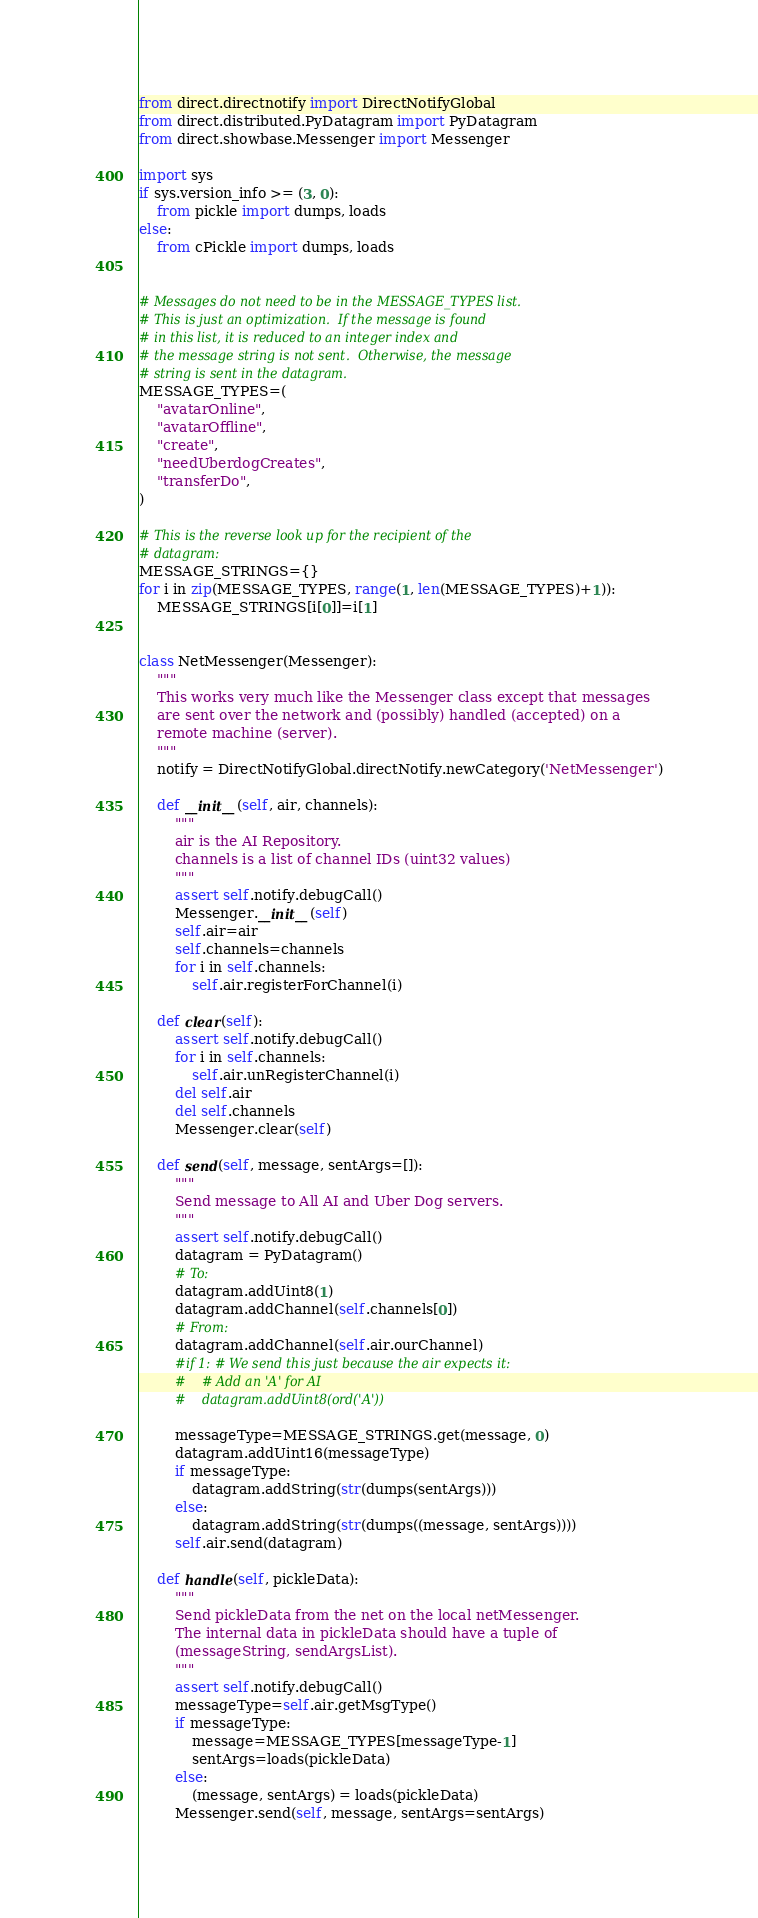Convert code to text. <code><loc_0><loc_0><loc_500><loc_500><_Python_>
from direct.directnotify import DirectNotifyGlobal
from direct.distributed.PyDatagram import PyDatagram
from direct.showbase.Messenger import Messenger

import sys
if sys.version_info >= (3, 0):
    from pickle import dumps, loads
else:
    from cPickle import dumps, loads


# Messages do not need to be in the MESSAGE_TYPES list.
# This is just an optimization.  If the message is found
# in this list, it is reduced to an integer index and
# the message string is not sent.  Otherwise, the message
# string is sent in the datagram.
MESSAGE_TYPES=(
    "avatarOnline",
    "avatarOffline",
    "create",
    "needUberdogCreates",
    "transferDo",
)

# This is the reverse look up for the recipient of the
# datagram:
MESSAGE_STRINGS={}
for i in zip(MESSAGE_TYPES, range(1, len(MESSAGE_TYPES)+1)):
    MESSAGE_STRINGS[i[0]]=i[1]


class NetMessenger(Messenger):
    """
    This works very much like the Messenger class except that messages
    are sent over the network and (possibly) handled (accepted) on a
    remote machine (server).
    """
    notify = DirectNotifyGlobal.directNotify.newCategory('NetMessenger')

    def __init__(self, air, channels):
        """
        air is the AI Repository.
        channels is a list of channel IDs (uint32 values)
        """
        assert self.notify.debugCall()
        Messenger.__init__(self)
        self.air=air
        self.channels=channels
        for i in self.channels:
            self.air.registerForChannel(i)

    def clear(self):
        assert self.notify.debugCall()
        for i in self.channels:
            self.air.unRegisterChannel(i)
        del self.air
        del self.channels
        Messenger.clear(self)

    def send(self, message, sentArgs=[]):
        """
        Send message to All AI and Uber Dog servers.
        """
        assert self.notify.debugCall()
        datagram = PyDatagram()
        # To:
        datagram.addUint8(1)
        datagram.addChannel(self.channels[0])
        # From:
        datagram.addChannel(self.air.ourChannel)
        #if 1: # We send this just because the air expects it:
        #    # Add an 'A' for AI
        #    datagram.addUint8(ord('A'))

        messageType=MESSAGE_STRINGS.get(message, 0)
        datagram.addUint16(messageType)
        if messageType:
            datagram.addString(str(dumps(sentArgs)))
        else:
            datagram.addString(str(dumps((message, sentArgs))))
        self.air.send(datagram)

    def handle(self, pickleData):
        """
        Send pickleData from the net on the local netMessenger.
        The internal data in pickleData should have a tuple of
        (messageString, sendArgsList).
        """
        assert self.notify.debugCall()
        messageType=self.air.getMsgType()
        if messageType:
            message=MESSAGE_TYPES[messageType-1]
            sentArgs=loads(pickleData)
        else:
            (message, sentArgs) = loads(pickleData)
        Messenger.send(self, message, sentArgs=sentArgs)


</code> 